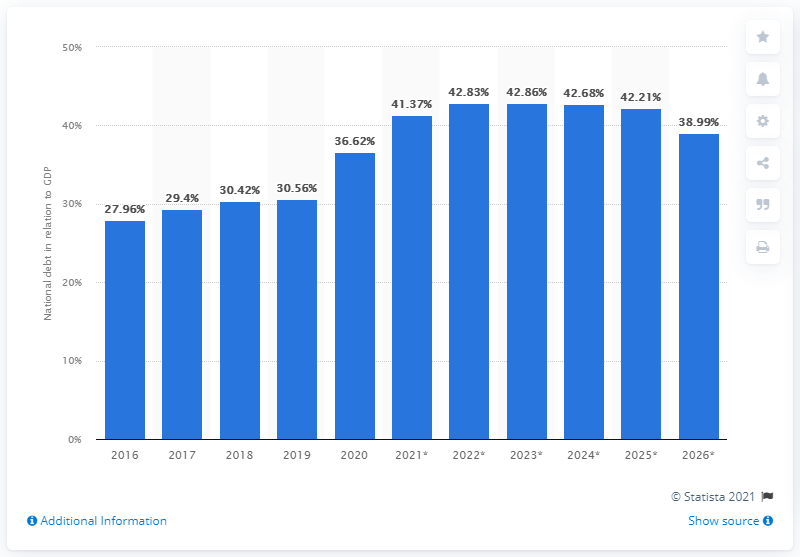Specify some key components in this picture. In 2020, the national debt of Indonesia accounted for approximately 36.62% of the country's Gross Domestic Product (GDP). 